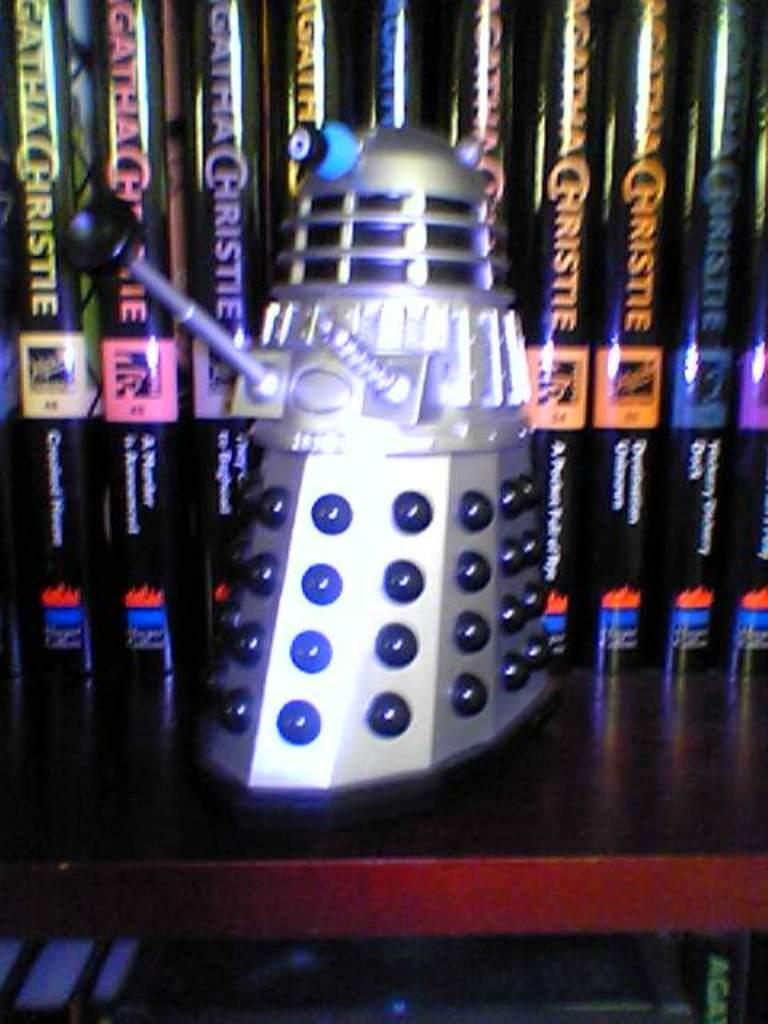<image>
Give a short and clear explanation of the subsequent image. A small robot replica on a shelf in front of a variety of Agatha Christie novels. 